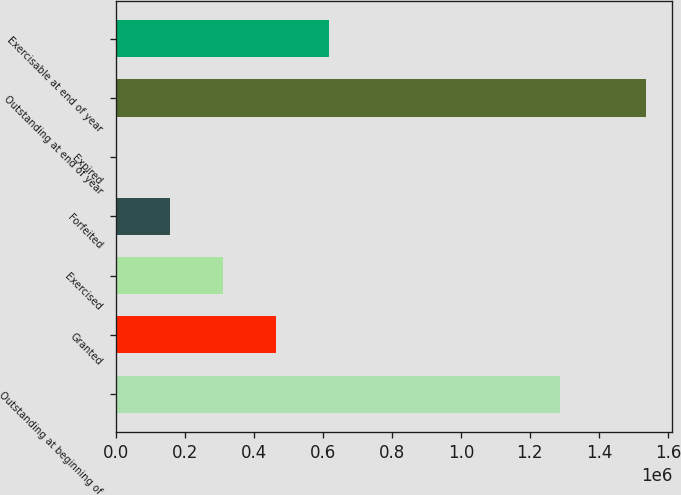<chart> <loc_0><loc_0><loc_500><loc_500><bar_chart><fcel>Outstanding at beginning of<fcel>Granted<fcel>Exercised<fcel>Forfeited<fcel>Expired<fcel>Outstanding at end of year<fcel>Exercisable at end of year<nl><fcel>1.28772e+06<fcel>463548<fcel>310369<fcel>157189<fcel>4010<fcel>1.5358e+06<fcel>616728<nl></chart> 